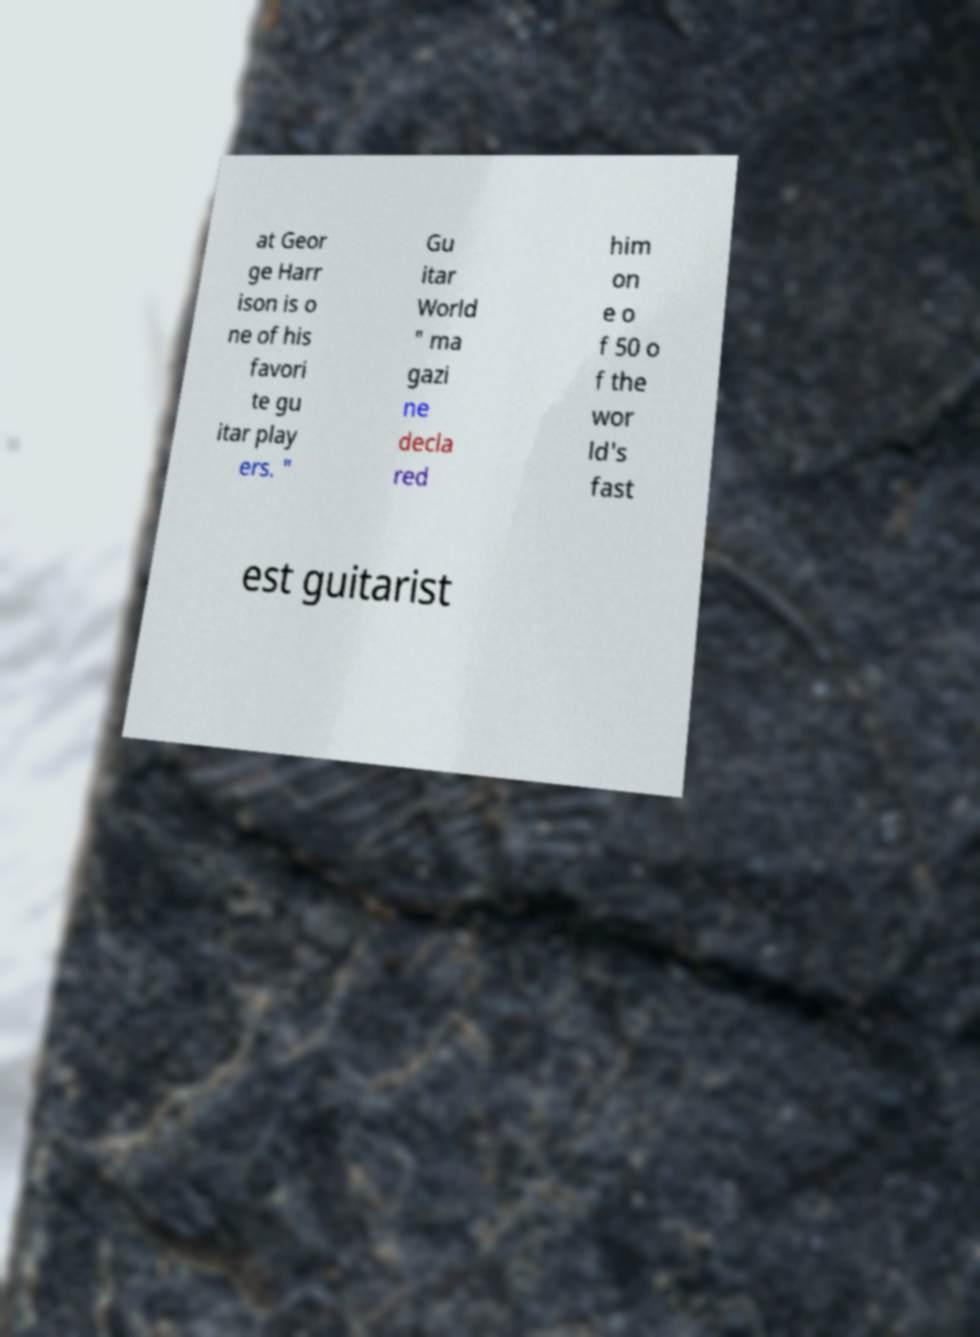Can you accurately transcribe the text from the provided image for me? at Geor ge Harr ison is o ne of his favori te gu itar play ers. " Gu itar World " ma gazi ne decla red him on e o f 50 o f the wor ld's fast est guitarist 